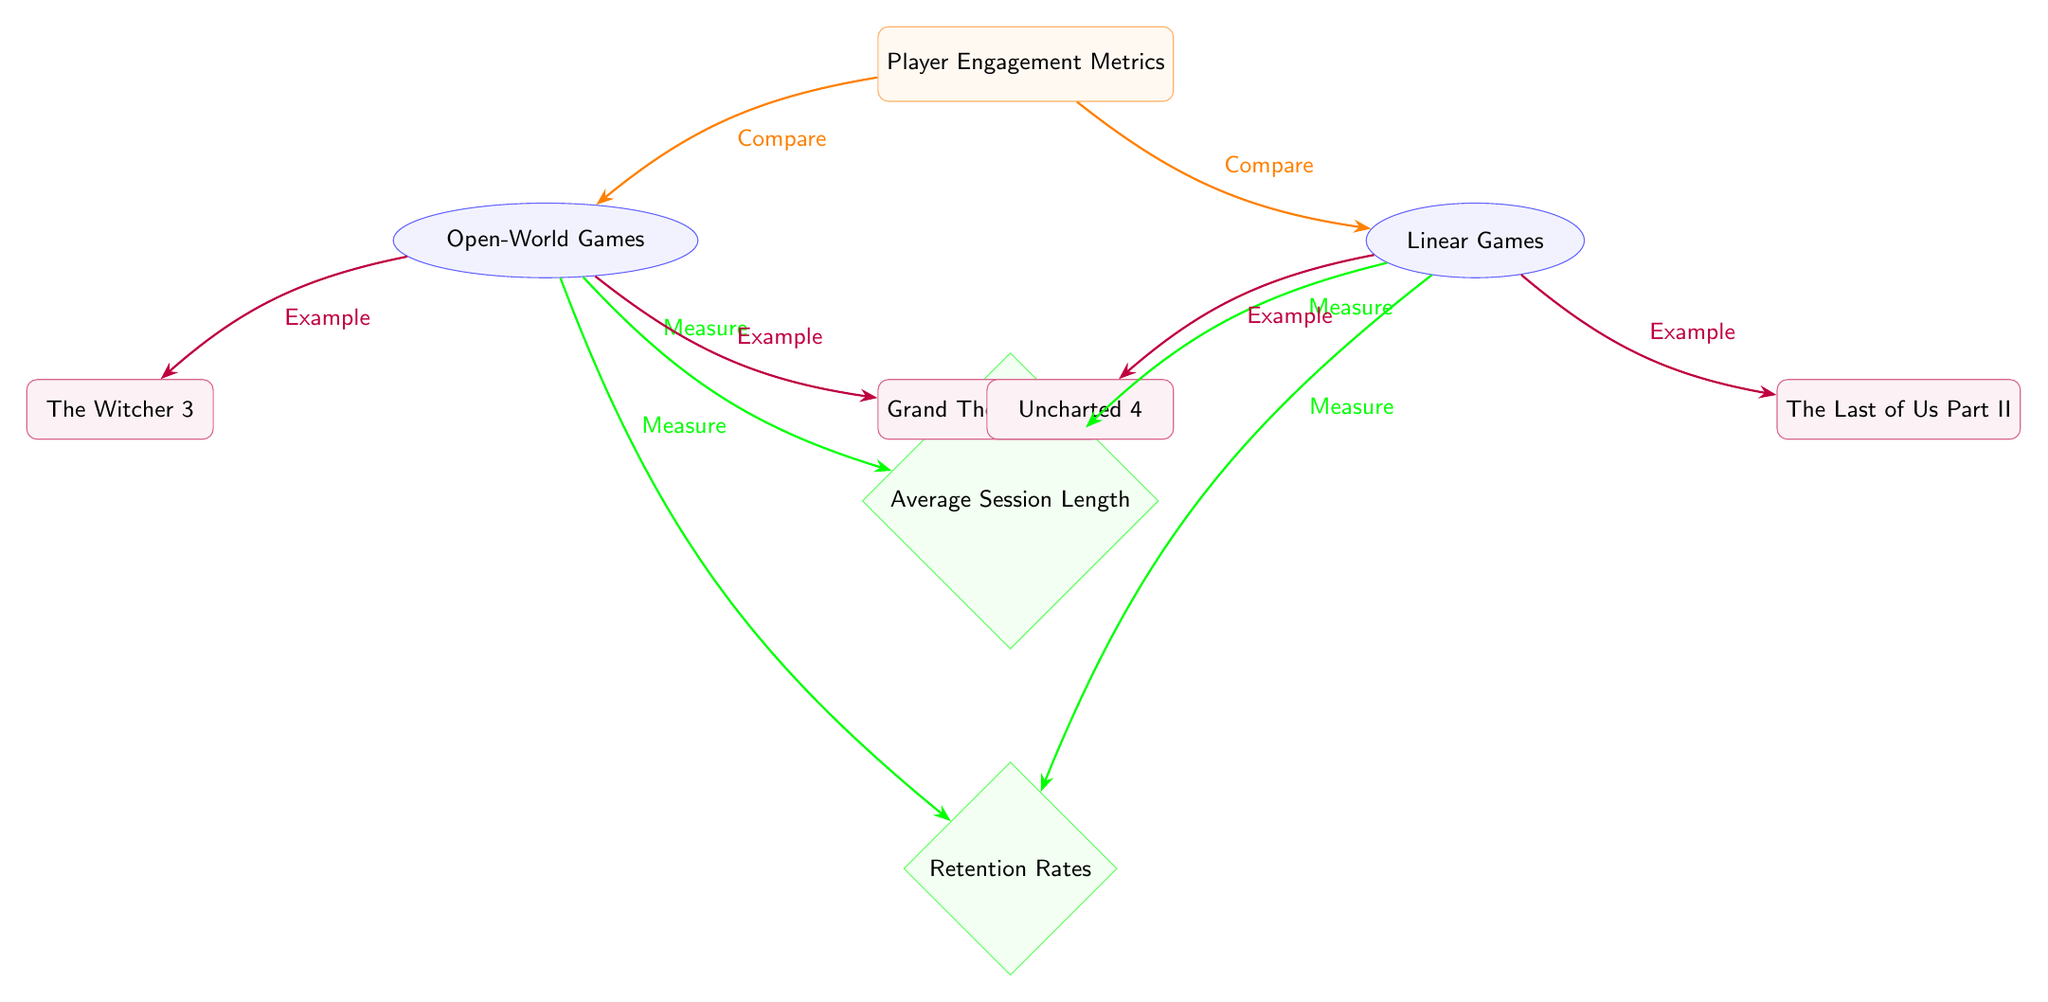What are the two types of games compared in the diagram? The diagram specifically compares Open-World Games and Linear Games as indicated by the labels beneath the main node "Player Engagement Metrics."
Answer: Open-World Games and Linear Games What metric is used to measure player engagement related to session duration? The diagram shows "Average Session Length" as a metric connected to both Open-World and Linear Games, indicating that it measures the duration of gameplay sessions.
Answer: Average Session Length How many games are listed as examples under Open-World Games? Upon inspecting the nodes, there are two games listed under the Open-World Games category, which are "The Witcher 3" and "Grand Theft Auto V."
Answer: 2 Which game is specifically mentioned as an example of a Linear Game? Referring to the diagram, "Uncharted 4" is provided as one of the examples listed under Linear Games.
Answer: Uncharted 4 What relationship do the retention rates have with both types of games? The diagram indicates that "Retention Rates" is a metric measured for both types of games, thus establishing a relationship where both Open-World and Linear Games assess retention metrics.
Answer: Measure Explain the flow of measurement from the types of games to the engagement metrics. Both game types, Open-World and Linear, connect to the "Average Session Length" and "Retention Rates" metrics through directed arrows labeled "Measure," illustrating that these games are measured against the same engagement metrics.
Answer: Measure How many metrics are represented in the diagram? The diagram illustrates two metrics: "Average Session Length" and "Retention Rates." Each metric branches off from both game types indicating their relevance to player engagement.
Answer: 2 Which game example is connected to the Open-World Games? The diagram shows two explicit game examples — "The Witcher 3" and "Grand Theft Auto V," which are directly connected to Open-World Games.
Answer: The Witcher 3 and Grand Theft Auto V 